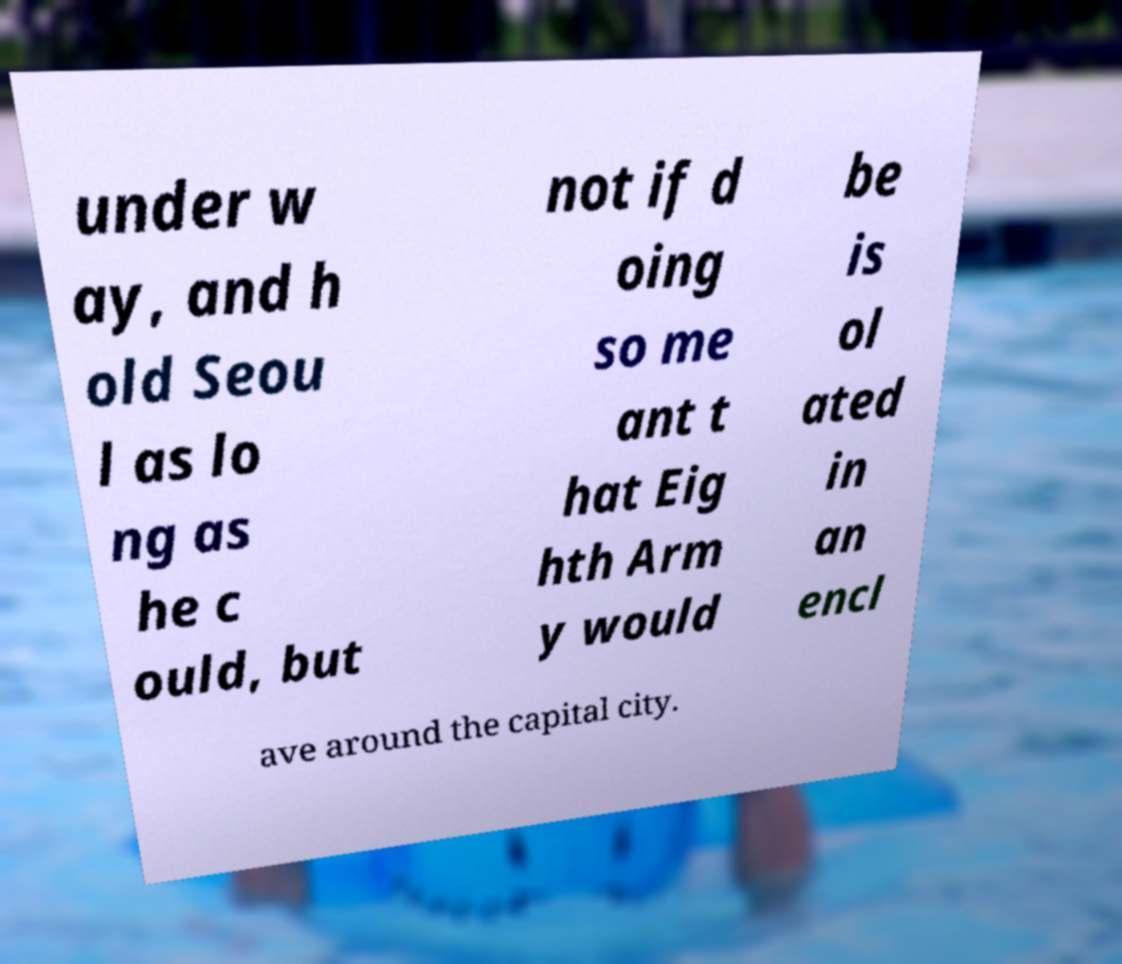Please identify and transcribe the text found in this image. under w ay, and h old Seou l as lo ng as he c ould, but not if d oing so me ant t hat Eig hth Arm y would be is ol ated in an encl ave around the capital city. 